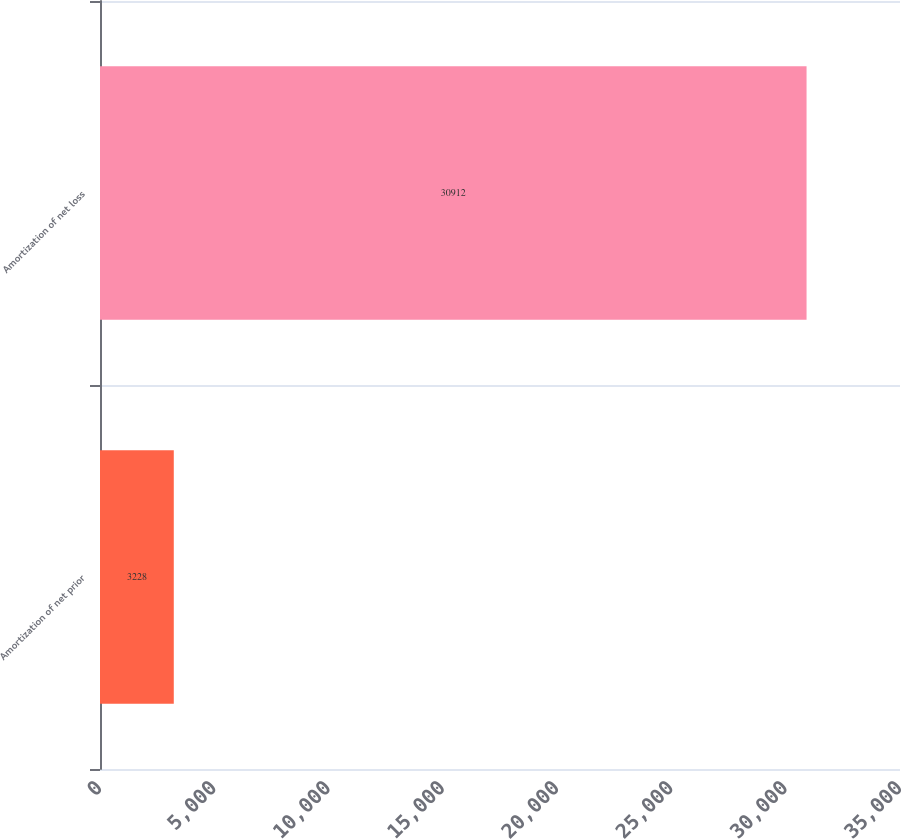Convert chart. <chart><loc_0><loc_0><loc_500><loc_500><bar_chart><fcel>Amortization of net prior<fcel>Amortization of net loss<nl><fcel>3228<fcel>30912<nl></chart> 